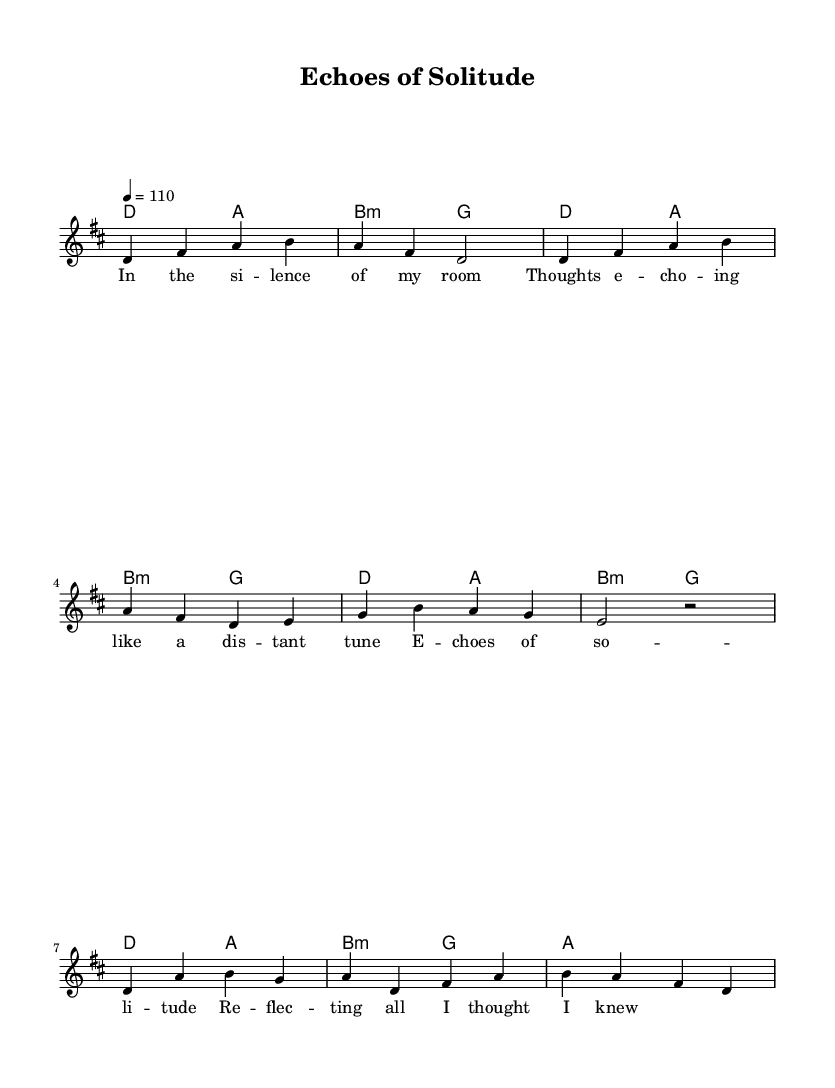What is the key signature of this music? The key signature is indicated by the number of sharps or flats at the beginning of the staff. In this case, there are two sharps, which corresponds to D major.
Answer: D major What is the time signature of this piece? The time signature is shown at the beginning of the music as a fraction. Here, it is 4/4, meaning there are four beats per measure.
Answer: 4/4 What is the tempo marking for this piece? The tempo marking is found at the start of the score and specifies the beats per minute. In this sheet music, it is indicated as 110 beats per minute.
Answer: 110 How many measures are in the chorus section? To find the number of measures in the chorus, we can count the notation representing the chorus in the music. It contains four measures.
Answer: 4 Which section of the song features the lyrics "Echoes of solitude"? The lyrics "Echoes of solitude" are part of the chorus. We can see this by identifying the specific lyrics marked in relation to the melody notes.
Answer: Chorus Is there a repeated section in the music? By analyzing the structure, we can see that the first four measures of the verse are identical in pitch and rhythm to the first four measures of the chorus, indicating a repeated melodic motif.
Answer: Yes What is the last chord played in the piece? The last chord can be found at the end of the harmonic section in the score. The final chord shown is A major, as indicated in the chord notation.
Answer: A major 